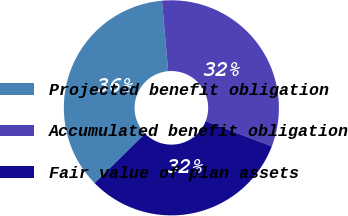Convert chart to OTSL. <chart><loc_0><loc_0><loc_500><loc_500><pie_chart><fcel>Projected benefit obligation<fcel>Accumulated benefit obligation<fcel>Fair value of plan assets<nl><fcel>35.95%<fcel>32.23%<fcel>31.82%<nl></chart> 